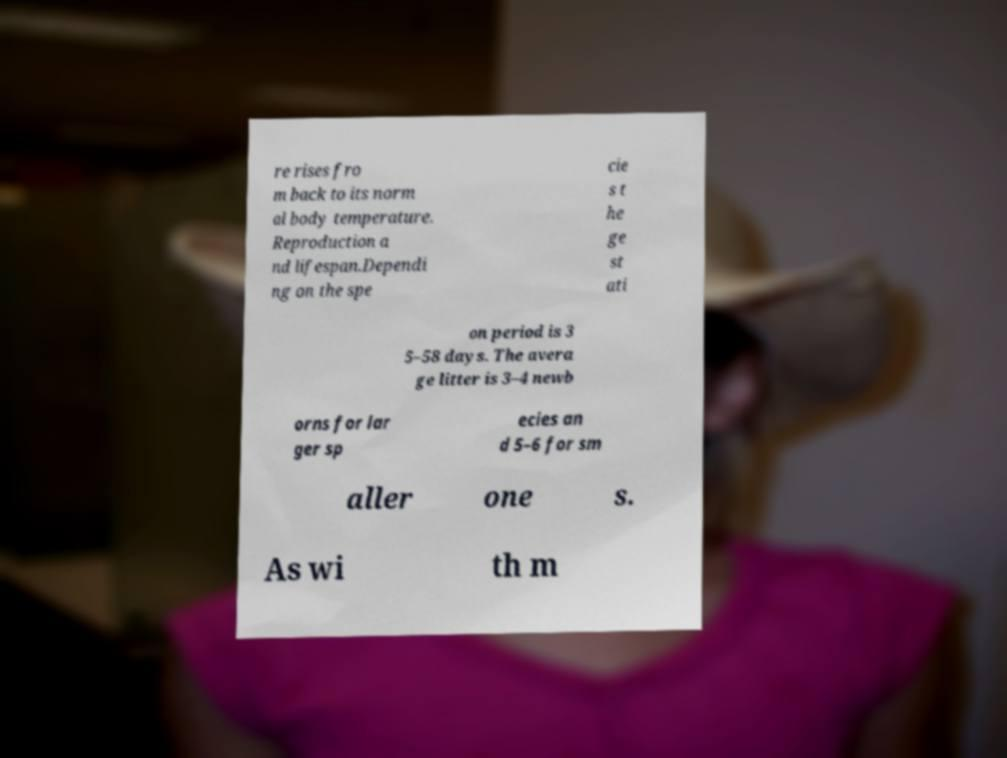There's text embedded in this image that I need extracted. Can you transcribe it verbatim? re rises fro m back to its norm al body temperature. Reproduction a nd lifespan.Dependi ng on the spe cie s t he ge st ati on period is 3 5–58 days. The avera ge litter is 3–4 newb orns for lar ger sp ecies an d 5–6 for sm aller one s. As wi th m 